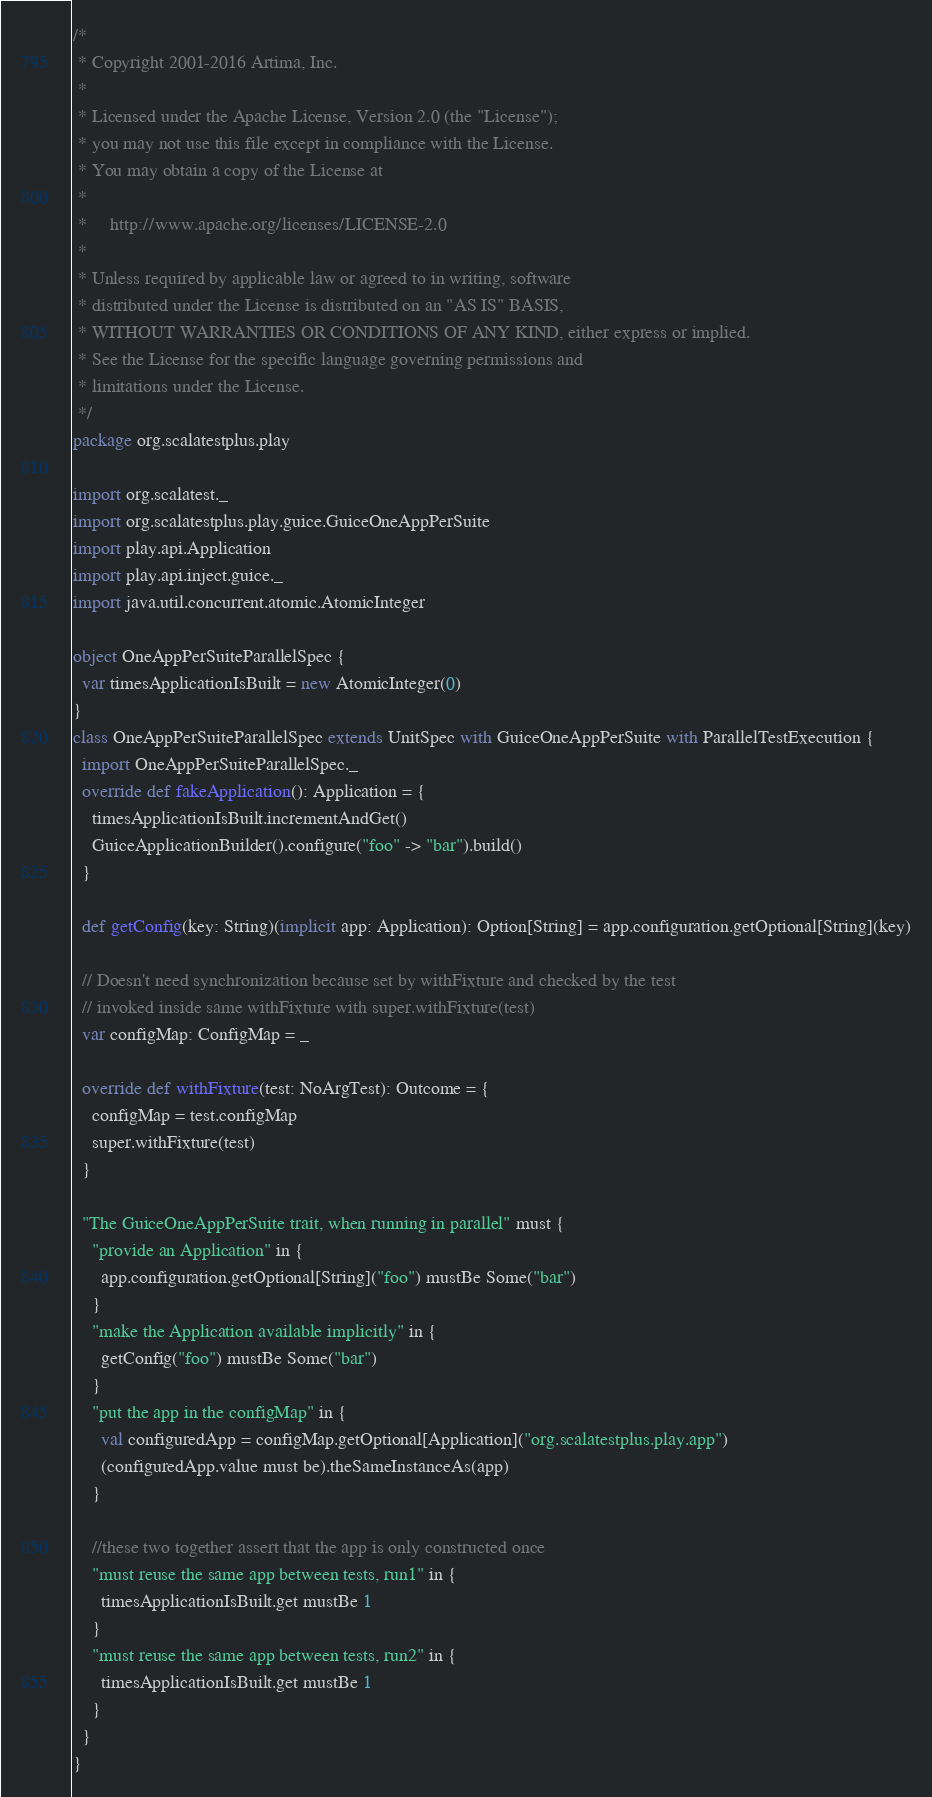Convert code to text. <code><loc_0><loc_0><loc_500><loc_500><_Scala_>/*
 * Copyright 2001-2016 Artima, Inc.
 *
 * Licensed under the Apache License, Version 2.0 (the "License");
 * you may not use this file except in compliance with the License.
 * You may obtain a copy of the License at
 *
 *     http://www.apache.org/licenses/LICENSE-2.0
 *
 * Unless required by applicable law or agreed to in writing, software
 * distributed under the License is distributed on an "AS IS" BASIS,
 * WITHOUT WARRANTIES OR CONDITIONS OF ANY KIND, either express or implied.
 * See the License for the specific language governing permissions and
 * limitations under the License.
 */
package org.scalatestplus.play

import org.scalatest._
import org.scalatestplus.play.guice.GuiceOneAppPerSuite
import play.api.Application
import play.api.inject.guice._
import java.util.concurrent.atomic.AtomicInteger

object OneAppPerSuiteParallelSpec {
  var timesApplicationIsBuilt = new AtomicInteger(0)
}
class OneAppPerSuiteParallelSpec extends UnitSpec with GuiceOneAppPerSuite with ParallelTestExecution {
  import OneAppPerSuiteParallelSpec._
  override def fakeApplication(): Application = {
    timesApplicationIsBuilt.incrementAndGet()
    GuiceApplicationBuilder().configure("foo" -> "bar").build()
  }

  def getConfig(key: String)(implicit app: Application): Option[String] = app.configuration.getOptional[String](key)

  // Doesn't need synchronization because set by withFixture and checked by the test
  // invoked inside same withFixture with super.withFixture(test)
  var configMap: ConfigMap = _

  override def withFixture(test: NoArgTest): Outcome = {
    configMap = test.configMap
    super.withFixture(test)
  }

  "The GuiceOneAppPerSuite trait, when running in parallel" must {
    "provide an Application" in {
      app.configuration.getOptional[String]("foo") mustBe Some("bar")
    }
    "make the Application available implicitly" in {
      getConfig("foo") mustBe Some("bar")
    }
    "put the app in the configMap" in {
      val configuredApp = configMap.getOptional[Application]("org.scalatestplus.play.app")
      (configuredApp.value must be).theSameInstanceAs(app)
    }

    //these two together assert that the app is only constructed once
    "must reuse the same app between tests, run1" in {
      timesApplicationIsBuilt.get mustBe 1
    }
    "must reuse the same app between tests, run2" in {
      timesApplicationIsBuilt.get mustBe 1
    }
  }
}
</code> 